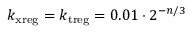<formula> <loc_0><loc_0><loc_500><loc_500>k _ { x r e g } = k _ { t r e g } = 0 . 0 1 \cdot 2 ^ { - n / 3 }</formula> 